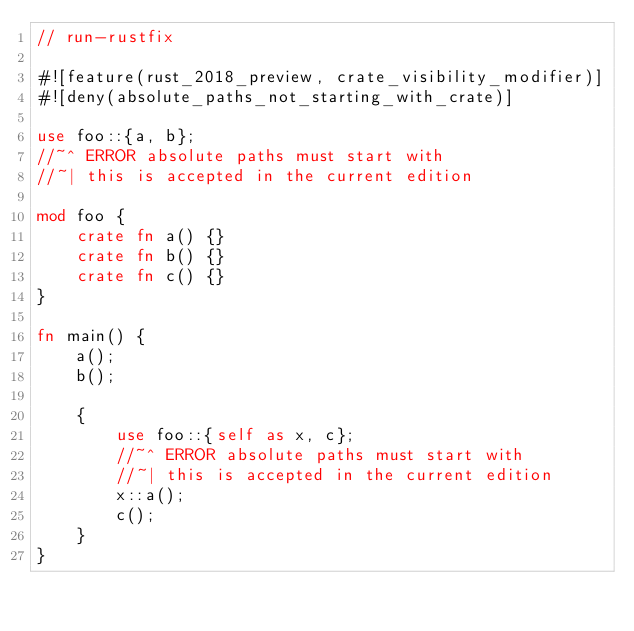Convert code to text. <code><loc_0><loc_0><loc_500><loc_500><_Rust_>// run-rustfix

#![feature(rust_2018_preview, crate_visibility_modifier)]
#![deny(absolute_paths_not_starting_with_crate)]

use foo::{a, b};
//~^ ERROR absolute paths must start with
//~| this is accepted in the current edition

mod foo {
    crate fn a() {}
    crate fn b() {}
    crate fn c() {}
}

fn main() {
    a();
    b();

    {
        use foo::{self as x, c};
        //~^ ERROR absolute paths must start with
        //~| this is accepted in the current edition
        x::a();
        c();
    }
}
</code> 